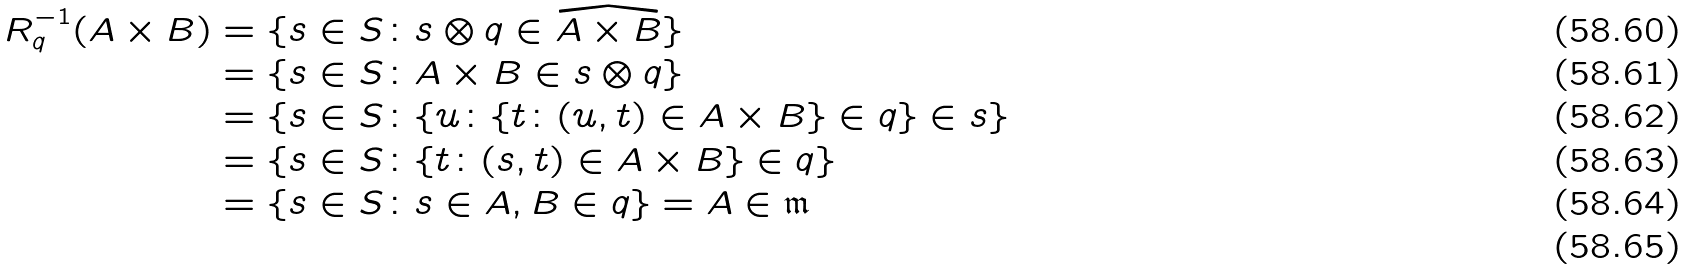Convert formula to latex. <formula><loc_0><loc_0><loc_500><loc_500>R _ { q } ^ { - 1 } ( A \times B ) & = \{ s \in S \colon s \otimes q \in \widehat { A \times B } \} \\ & = \{ s \in S \colon A \times B \in s \otimes q \} \\ & = \{ s \in S \colon \{ u \colon \{ t \colon ( u , t ) \in A \times B \} \in q \} \in s \} \\ & = \{ s \in S \colon \{ t \colon ( s , t ) \in A \times B \} \in q \} \\ & = \{ s \in S \colon s \in A , B \in q \} = A \in \mathfrak { m } \\</formula> 